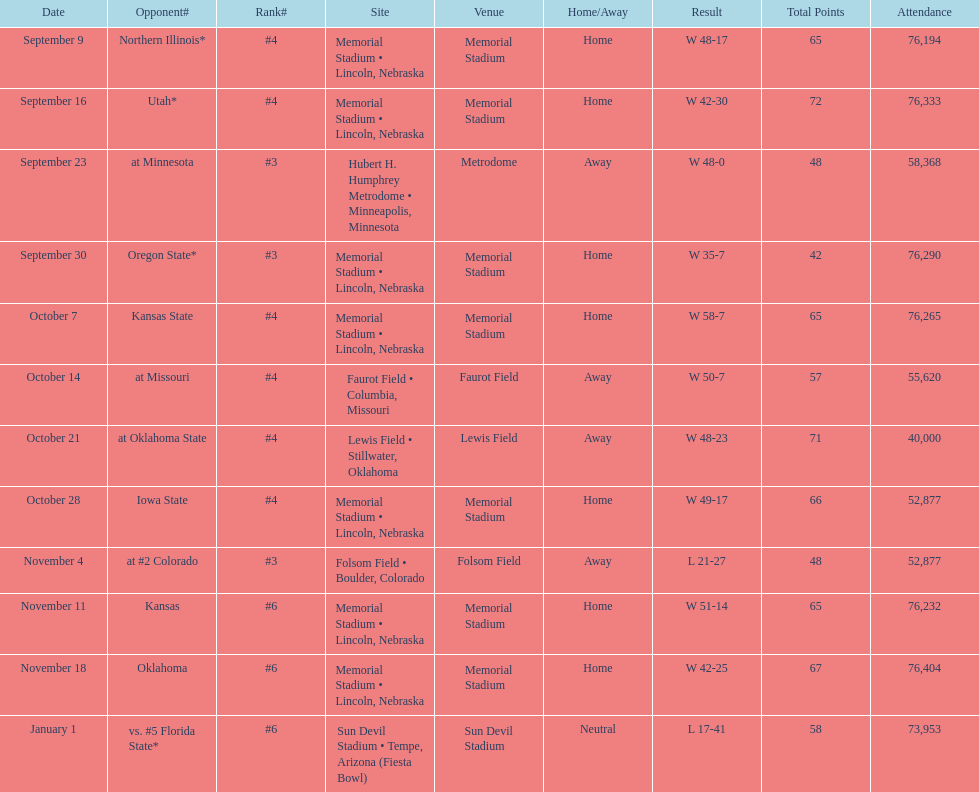On average how many times was w listed as the result? 10. 